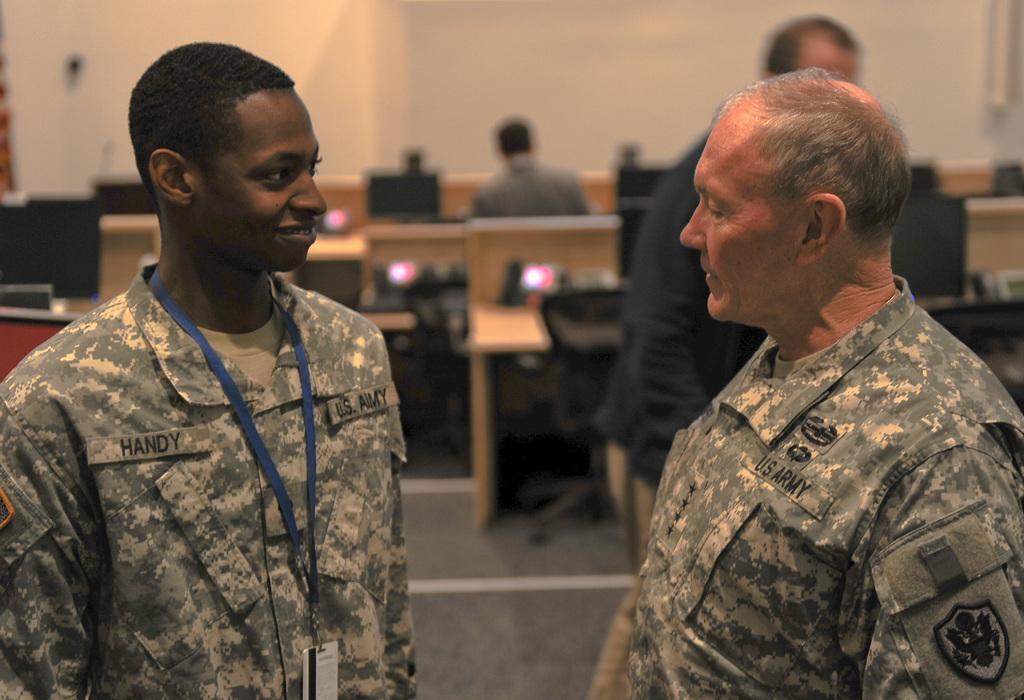In one or two sentences, can you explain what this image depicts? This is the picture of a room. In the foreground there are two persons standing. At the back there is a person standing and there is a person sitting. At the back there are computers and devices on the tables and there are chairs and there is a wall. 